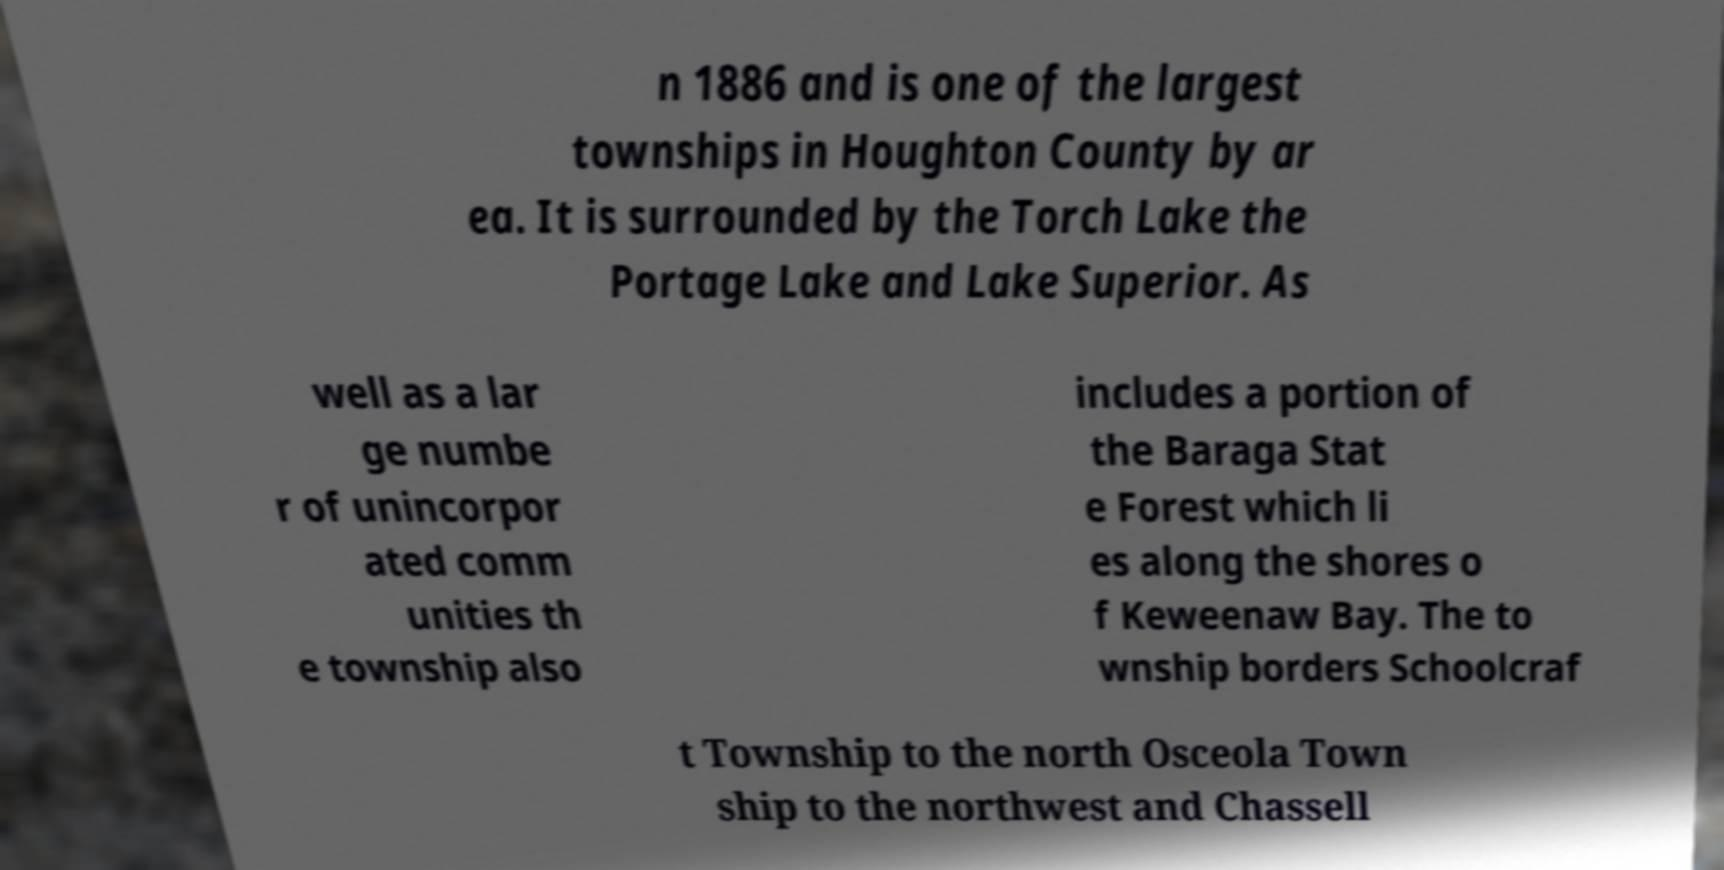Could you extract and type out the text from this image? n 1886 and is one of the largest townships in Houghton County by ar ea. It is surrounded by the Torch Lake the Portage Lake and Lake Superior. As well as a lar ge numbe r of unincorpor ated comm unities th e township also includes a portion of the Baraga Stat e Forest which li es along the shores o f Keweenaw Bay. The to wnship borders Schoolcraf t Township to the north Osceola Town ship to the northwest and Chassell 